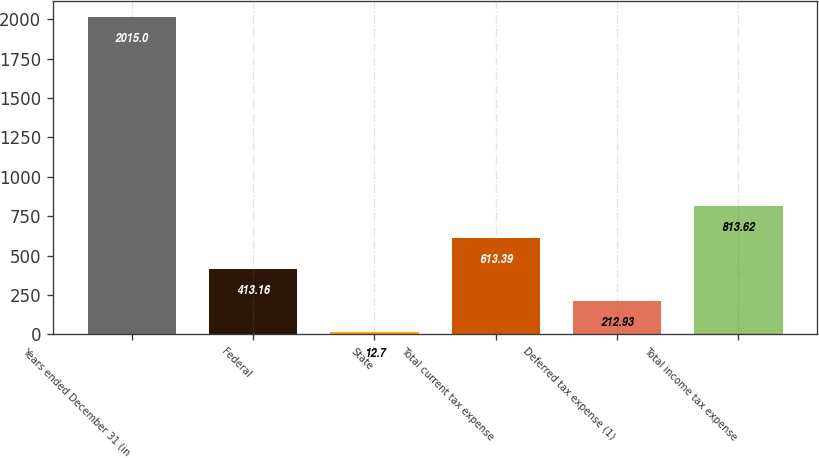Convert chart to OTSL. <chart><loc_0><loc_0><loc_500><loc_500><bar_chart><fcel>Years ended December 31 (in<fcel>Federal<fcel>State<fcel>Total current tax expense<fcel>Deferred tax expense (1)<fcel>Total income tax expense<nl><fcel>2015<fcel>413.16<fcel>12.7<fcel>613.39<fcel>212.93<fcel>813.62<nl></chart> 